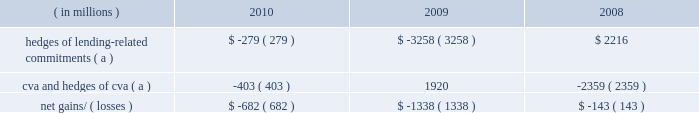Management 2019s discussion and analysis 128 jpmorgan chase & co./2010 annual report year ended december 31 .
( a ) these hedges do not qualify for hedge accounting under u.s .
Gaap .
Lending-related commitments jpmorgan chase uses lending-related financial instruments , such as commitments and guarantees , to meet the financing needs of its customers .
The contractual amount of these financial instruments represents the maximum possible credit risk should the counterpar- ties draw down on these commitments or the firm fulfills its obliga- tion under these guarantees , and should the counterparties subsequently fail to perform according to the terms of these con- tracts .
Wholesale lending-related commitments were $ 346.1 billion at december 31 , 2010 , compared with $ 347.2 billion at december 31 , 2009 .
The decrease reflected the january 1 , 2010 , adoption of accounting guidance related to vies .
Excluding the effect of the accounting guidance , lending-related commitments would have increased by $ 16.6 billion .
In the firm 2019s view , the total contractual amount of these wholesale lending-related commitments is not representative of the firm 2019s actual credit risk exposure or funding requirements .
In determining the amount of credit risk exposure the firm has to wholesale lend- ing-related commitments , which is used as the basis for allocating credit risk capital to these commitments , the firm has established a 201cloan-equivalent 201d amount for each commitment ; this amount represents the portion of the unused commitment or other contin- gent exposure that is expected , based on average portfolio histori- cal experience , to become drawn upon in an event of a default by an obligor .
The loan-equivalent amounts of the firm 2019s lending- related commitments were $ 189.9 billion and $ 179.8 billion as of december 31 , 2010 and 2009 , respectively .
Country exposure the firm 2019s wholesale portfolio includes country risk exposures to both developed and emerging markets .
The firm seeks to diversify its country exposures , including its credit-related lending , trading and investment activities , whether cross-border or locally funded .
Country exposure under the firm 2019s internal risk management ap- proach is reported based on the country where the assets of the obligor , counterparty or guarantor are located .
Exposure amounts , including resale agreements , are adjusted for collateral and for credit enhancements ( e.g. , guarantees and letters of credit ) pro- vided by third parties ; outstandings supported by a guarantor located outside the country or backed by collateral held outside the country are assigned to the country of the enhancement provider .
In addition , the effect of credit derivative hedges and other short credit or equity trading positions are taken into consideration .
Total exposure measures include activity with both government and private-sector entities in a country .
The firm also reports country exposure for regulatory purposes following ffiec guidelines , which are different from the firm 2019s internal risk management approach for measuring country expo- sure .
For additional information on the ffiec exposures , see cross- border outstandings on page 314 of this annual report .
Several european countries , including greece , portugal , spain , italy and ireland , have been subject to credit deterioration due to weak- nesses in their economic and fiscal situations .
The firm is closely monitoring its exposures to these five countries .
Aggregate net exposures to these five countries as measured under the firm 2019s internal approach was less than $ 15.0 billion at december 31 , 2010 , with no country representing a majority of the exposure .
Sovereign exposure in all five countries represented less than half the aggregate net exposure .
The firm currently believes its exposure to these five countries is modest relative to the firm 2019s overall risk expo- sures and is manageable given the size and types of exposures to each of the countries and the diversification of the aggregate expo- sure .
The firm continues to conduct business and support client activity in these countries and , therefore , the firm 2019s aggregate net exposures may vary over time .
In addition , the net exposures may be impacted by changes in market conditions , and the effects of interest rates and credit spreads on market valuations .
As part of its ongoing country risk management process , the firm monitors exposure to emerging market countries , and utilizes country stress tests to measure and manage the risk of extreme loss associated with a sovereign crisis .
There is no common definition of emerging markets , but the firm generally includes in its definition those countries whose sovereign debt ratings are equivalent to 201ca+ 201d or lower .
The table below presents the firm 2019s exposure to its top 10 emerging markets countries based on its internal measure- ment approach .
The selection of countries is based solely on the firm 2019s largest total exposures by country and does not represent its view of any actual or potentially adverse credit conditions. .
What was the ratio of the wholesale lending-related commitments in 2010 compared to 2009? 
Computations: (346.1 / 347.2)
Answer: 0.99683. 